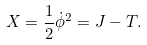Convert formula to latex. <formula><loc_0><loc_0><loc_500><loc_500>X = \frac { 1 } { 2 } \dot { \phi } ^ { 2 } = J - T .</formula> 